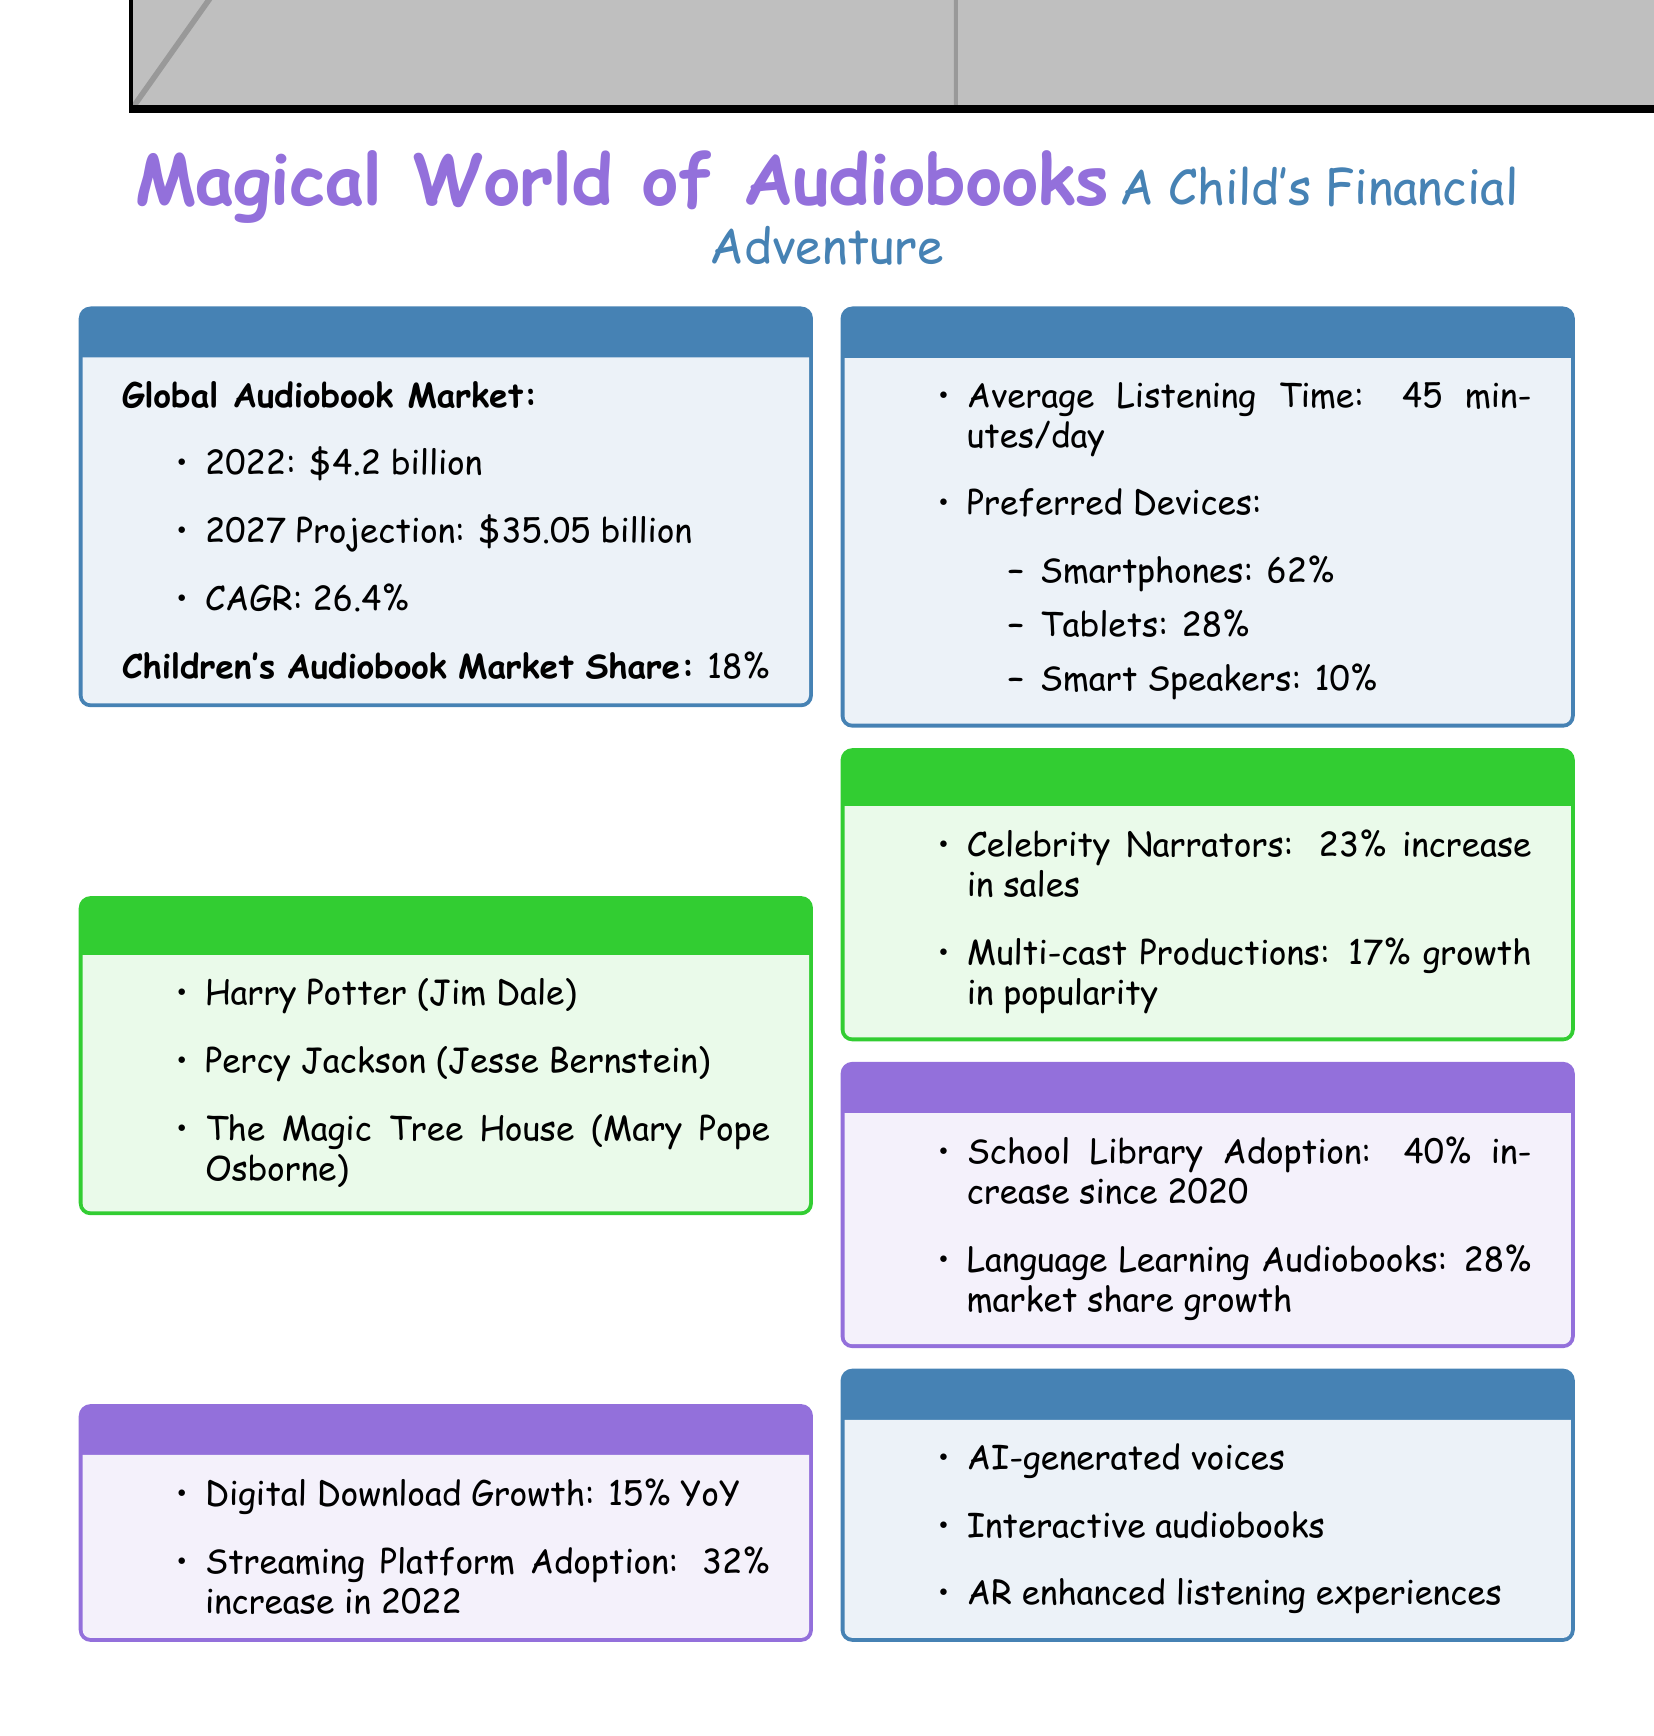What was the global audiobook market size in 2022? The document states that the global audiobook market size in 2022 was $4.2 billion.
Answer: $4.2 billion What is the projected global audiobook market size for 2027? According to the document, the projected market size for 2027 is $35.05 billion.
Answer: $35.05 billion What percentage of the total audiobook market do children's audiobooks represent? The document indicates that children's audiobooks represent 18% of the total audiobook market.
Answer: 18% Which children's audiobook series is narrated by Jim Dale? The document lists "Harry Potter" as the series narrated by Jim Dale.
Answer: Harry Potter What was the increase in streaming platform adoption in 2022? The document notes a 32% increase in streaming platform adoption during 2022.
Answer: 32% How much do sales increase due to celebrity narrators? The document mentions that celebrity narrators lead to a 23% increase in sales.
Answer: 23% What was the average listening time per day? According to the document, the average listening time per day is 45 minutes.
Answer: 45 minutes What is one of the future trends in the audiobook industry mentioned in the report? The report lists "AI-generated voices" as a future trend in the audiobook industry.
Answer: AI-generated voices What percentage increase has there been in school library audiobook adoption since 2020? The document shows a 40% increase in school library audiobook adoption since 2020.
Answer: 40% 